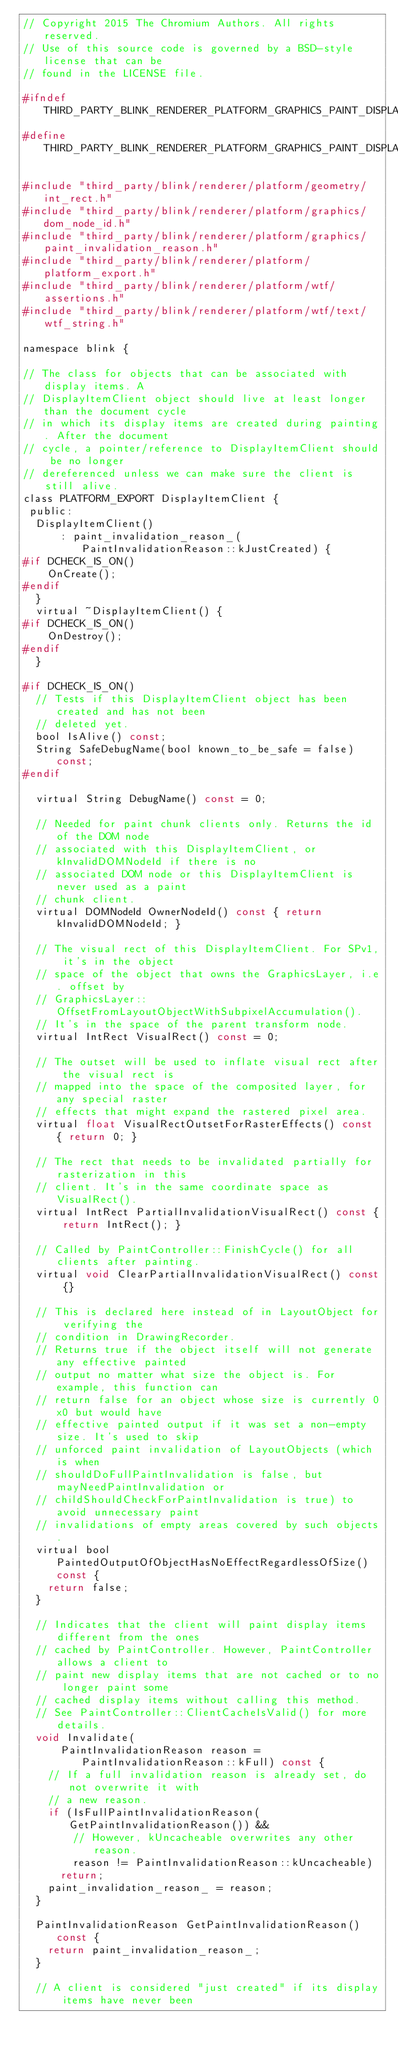<code> <loc_0><loc_0><loc_500><loc_500><_C_>// Copyright 2015 The Chromium Authors. All rights reserved.
// Use of this source code is governed by a BSD-style license that can be
// found in the LICENSE file.

#ifndef THIRD_PARTY_BLINK_RENDERER_PLATFORM_GRAPHICS_PAINT_DISPLAY_ITEM_CLIENT_H_
#define THIRD_PARTY_BLINK_RENDERER_PLATFORM_GRAPHICS_PAINT_DISPLAY_ITEM_CLIENT_H_

#include "third_party/blink/renderer/platform/geometry/int_rect.h"
#include "third_party/blink/renderer/platform/graphics/dom_node_id.h"
#include "third_party/blink/renderer/platform/graphics/paint_invalidation_reason.h"
#include "third_party/blink/renderer/platform/platform_export.h"
#include "third_party/blink/renderer/platform/wtf/assertions.h"
#include "third_party/blink/renderer/platform/wtf/text/wtf_string.h"

namespace blink {

// The class for objects that can be associated with display items. A
// DisplayItemClient object should live at least longer than the document cycle
// in which its display items are created during painting. After the document
// cycle, a pointer/reference to DisplayItemClient should be no longer
// dereferenced unless we can make sure the client is still alive.
class PLATFORM_EXPORT DisplayItemClient {
 public:
  DisplayItemClient()
      : paint_invalidation_reason_(PaintInvalidationReason::kJustCreated) {
#if DCHECK_IS_ON()
    OnCreate();
#endif
  }
  virtual ~DisplayItemClient() {
#if DCHECK_IS_ON()
    OnDestroy();
#endif
  }

#if DCHECK_IS_ON()
  // Tests if this DisplayItemClient object has been created and has not been
  // deleted yet.
  bool IsAlive() const;
  String SafeDebugName(bool known_to_be_safe = false) const;
#endif

  virtual String DebugName() const = 0;

  // Needed for paint chunk clients only. Returns the id of the DOM node
  // associated with this DisplayItemClient, or kInvalidDOMNodeId if there is no
  // associated DOM node or this DisplayItemClient is never used as a paint
  // chunk client.
  virtual DOMNodeId OwnerNodeId() const { return kInvalidDOMNodeId; }

  // The visual rect of this DisplayItemClient. For SPv1, it's in the object
  // space of the object that owns the GraphicsLayer, i.e. offset by
  // GraphicsLayer::OffsetFromLayoutObjectWithSubpixelAccumulation().
  // It's in the space of the parent transform node.
  virtual IntRect VisualRect() const = 0;

  // The outset will be used to inflate visual rect after the visual rect is
  // mapped into the space of the composited layer, for any special raster
  // effects that might expand the rastered pixel area.
  virtual float VisualRectOutsetForRasterEffects() const { return 0; }

  // The rect that needs to be invalidated partially for rasterization in this
  // client. It's in the same coordinate space as VisualRect().
  virtual IntRect PartialInvalidationVisualRect() const { return IntRect(); }

  // Called by PaintController::FinishCycle() for all clients after painting.
  virtual void ClearPartialInvalidationVisualRect() const {}

  // This is declared here instead of in LayoutObject for verifying the
  // condition in DrawingRecorder.
  // Returns true if the object itself will not generate any effective painted
  // output no matter what size the object is. For example, this function can
  // return false for an object whose size is currently 0x0 but would have
  // effective painted output if it was set a non-empty size. It's used to skip
  // unforced paint invalidation of LayoutObjects (which is when
  // shouldDoFullPaintInvalidation is false, but mayNeedPaintInvalidation or
  // childShouldCheckForPaintInvalidation is true) to avoid unnecessary paint
  // invalidations of empty areas covered by such objects.
  virtual bool PaintedOutputOfObjectHasNoEffectRegardlessOfSize() const {
    return false;
  }

  // Indicates that the client will paint display items different from the ones
  // cached by PaintController. However, PaintController allows a client to
  // paint new display items that are not cached or to no longer paint some
  // cached display items without calling this method.
  // See PaintController::ClientCacheIsValid() for more details.
  void Invalidate(
      PaintInvalidationReason reason = PaintInvalidationReason::kFull) const {
    // If a full invalidation reason is already set, do not overwrite it with
    // a new reason.
    if (IsFullPaintInvalidationReason(GetPaintInvalidationReason()) &&
        // However, kUncacheable overwrites any other reason.
        reason != PaintInvalidationReason::kUncacheable)
      return;
    paint_invalidation_reason_ = reason;
  }

  PaintInvalidationReason GetPaintInvalidationReason() const {
    return paint_invalidation_reason_;
  }

  // A client is considered "just created" if its display items have never been</code> 